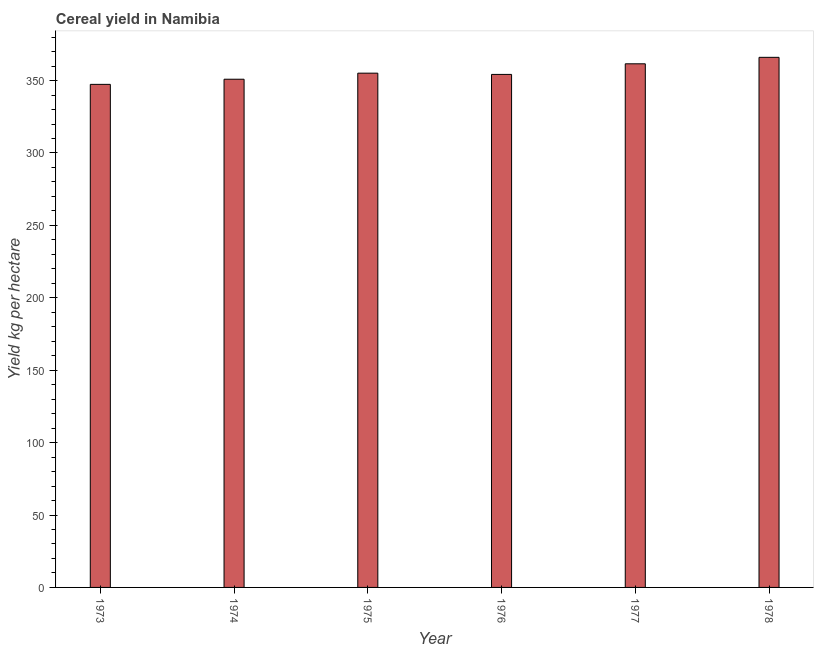Does the graph contain any zero values?
Keep it short and to the point. No. What is the title of the graph?
Offer a very short reply. Cereal yield in Namibia. What is the label or title of the Y-axis?
Offer a very short reply. Yield kg per hectare. What is the cereal yield in 1978?
Offer a terse response. 366.06. Across all years, what is the maximum cereal yield?
Ensure brevity in your answer.  366.06. Across all years, what is the minimum cereal yield?
Offer a very short reply. 347.39. In which year was the cereal yield maximum?
Make the answer very short. 1978. In which year was the cereal yield minimum?
Provide a short and direct response. 1973. What is the sum of the cereal yield?
Provide a succinct answer. 2135.37. What is the difference between the cereal yield in 1973 and 1978?
Your answer should be compact. -18.68. What is the average cereal yield per year?
Your answer should be very brief. 355.89. What is the median cereal yield?
Offer a very short reply. 354.69. What is the ratio of the cereal yield in 1974 to that in 1977?
Give a very brief answer. 0.97. Is the cereal yield in 1974 less than that in 1978?
Offer a very short reply. Yes. Is the difference between the cereal yield in 1973 and 1978 greater than the difference between any two years?
Your answer should be compact. Yes. What is the difference between the highest and the second highest cereal yield?
Provide a succinct answer. 4.47. Is the sum of the cereal yield in 1973 and 1974 greater than the maximum cereal yield across all years?
Offer a very short reply. Yes. What is the difference between the highest and the lowest cereal yield?
Give a very brief answer. 18.68. In how many years, is the cereal yield greater than the average cereal yield taken over all years?
Your response must be concise. 2. How many bars are there?
Keep it short and to the point. 6. How many years are there in the graph?
Provide a short and direct response. 6. Are the values on the major ticks of Y-axis written in scientific E-notation?
Make the answer very short. No. What is the Yield kg per hectare of 1973?
Make the answer very short. 347.39. What is the Yield kg per hectare in 1974?
Your answer should be compact. 350.94. What is the Yield kg per hectare in 1975?
Your response must be concise. 355.13. What is the Yield kg per hectare of 1976?
Ensure brevity in your answer.  354.26. What is the Yield kg per hectare in 1977?
Give a very brief answer. 361.59. What is the Yield kg per hectare of 1978?
Your answer should be compact. 366.06. What is the difference between the Yield kg per hectare in 1973 and 1974?
Provide a succinct answer. -3.55. What is the difference between the Yield kg per hectare in 1973 and 1975?
Your answer should be compact. -7.74. What is the difference between the Yield kg per hectare in 1973 and 1976?
Ensure brevity in your answer.  -6.87. What is the difference between the Yield kg per hectare in 1973 and 1977?
Provide a short and direct response. -14.2. What is the difference between the Yield kg per hectare in 1973 and 1978?
Offer a very short reply. -18.68. What is the difference between the Yield kg per hectare in 1974 and 1975?
Provide a short and direct response. -4.19. What is the difference between the Yield kg per hectare in 1974 and 1976?
Provide a succinct answer. -3.32. What is the difference between the Yield kg per hectare in 1974 and 1977?
Your response must be concise. -10.65. What is the difference between the Yield kg per hectare in 1974 and 1978?
Offer a terse response. -15.12. What is the difference between the Yield kg per hectare in 1975 and 1976?
Give a very brief answer. 0.87. What is the difference between the Yield kg per hectare in 1975 and 1977?
Offer a very short reply. -6.46. What is the difference between the Yield kg per hectare in 1975 and 1978?
Ensure brevity in your answer.  -10.93. What is the difference between the Yield kg per hectare in 1976 and 1977?
Give a very brief answer. -7.33. What is the difference between the Yield kg per hectare in 1976 and 1978?
Your answer should be compact. -11.8. What is the difference between the Yield kg per hectare in 1977 and 1978?
Keep it short and to the point. -4.47. What is the ratio of the Yield kg per hectare in 1973 to that in 1976?
Offer a very short reply. 0.98. What is the ratio of the Yield kg per hectare in 1973 to that in 1978?
Your answer should be very brief. 0.95. What is the ratio of the Yield kg per hectare in 1974 to that in 1975?
Ensure brevity in your answer.  0.99. What is the ratio of the Yield kg per hectare in 1974 to that in 1976?
Keep it short and to the point. 0.99. What is the ratio of the Yield kg per hectare in 1974 to that in 1977?
Give a very brief answer. 0.97. What is the ratio of the Yield kg per hectare in 1974 to that in 1978?
Offer a very short reply. 0.96. What is the ratio of the Yield kg per hectare in 1975 to that in 1976?
Make the answer very short. 1. What is the ratio of the Yield kg per hectare in 1975 to that in 1978?
Keep it short and to the point. 0.97. 